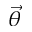Convert formula to latex. <formula><loc_0><loc_0><loc_500><loc_500>\vec { \theta }</formula> 